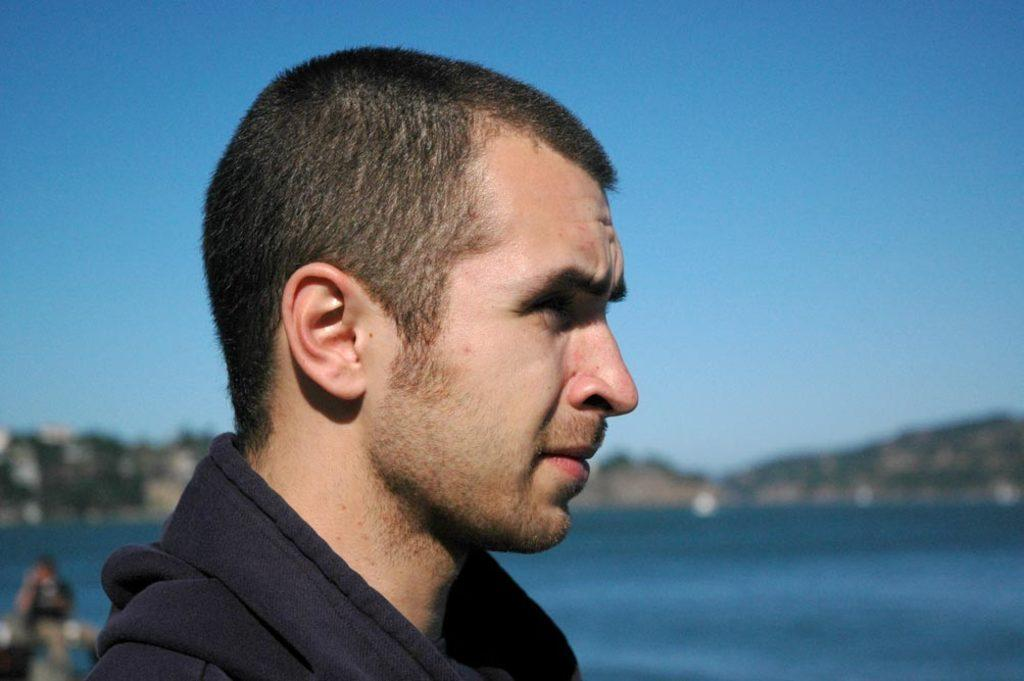Who is present in the image? There is a man in the image. What type of landscape can be seen in the image? There are hills visible in the image. What natural element is present in the image? There is water visible in the image. What part of the natural environment is visible in the image? The sky is visible in the image. How many giants can be seen in the image? There are no giants present in the image. What type of cattle is grazing near the water in the image? There is no cattle present in the image. 